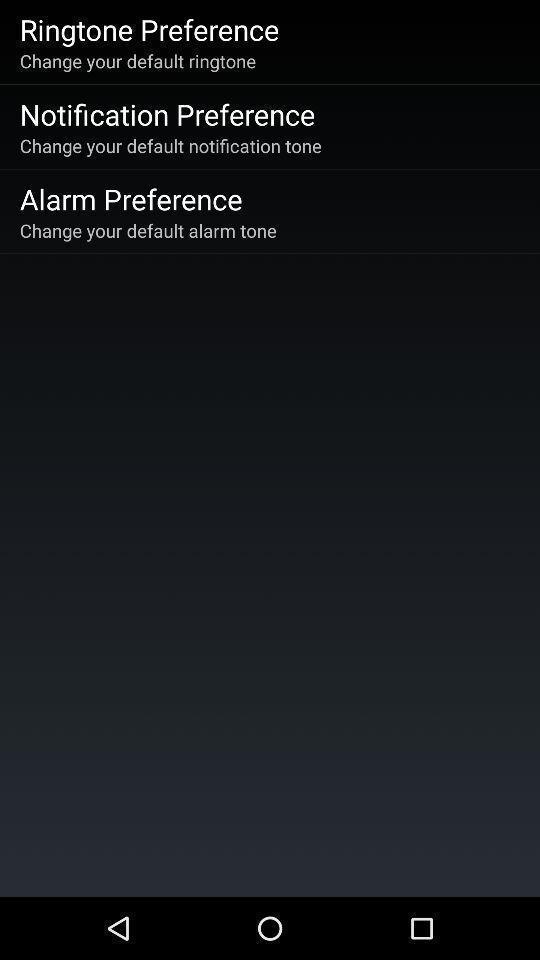What can you discern from this picture? Various preference options displayed. Provide a textual representation of this image. Screen showing reference page. 